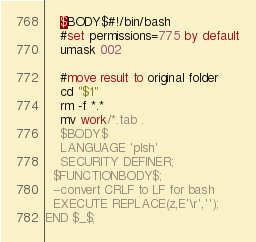<code> <loc_0><loc_0><loc_500><loc_500><_SQL_>    $BODY$#!/bin/bash
    #set permissions=775 by default
    umask 002

    #move result to original folder
    cd "$1"
    rm -f *.*
    mv work/*.tab .
    $BODY$
    LANGUAGE 'plsh'
    SECURITY DEFINER;
  $FUNCTIONBODY$;
  --convert CRLF to LF for bash
  EXECUTE REPLACE(z,E'\r','');
END $_$;</code> 